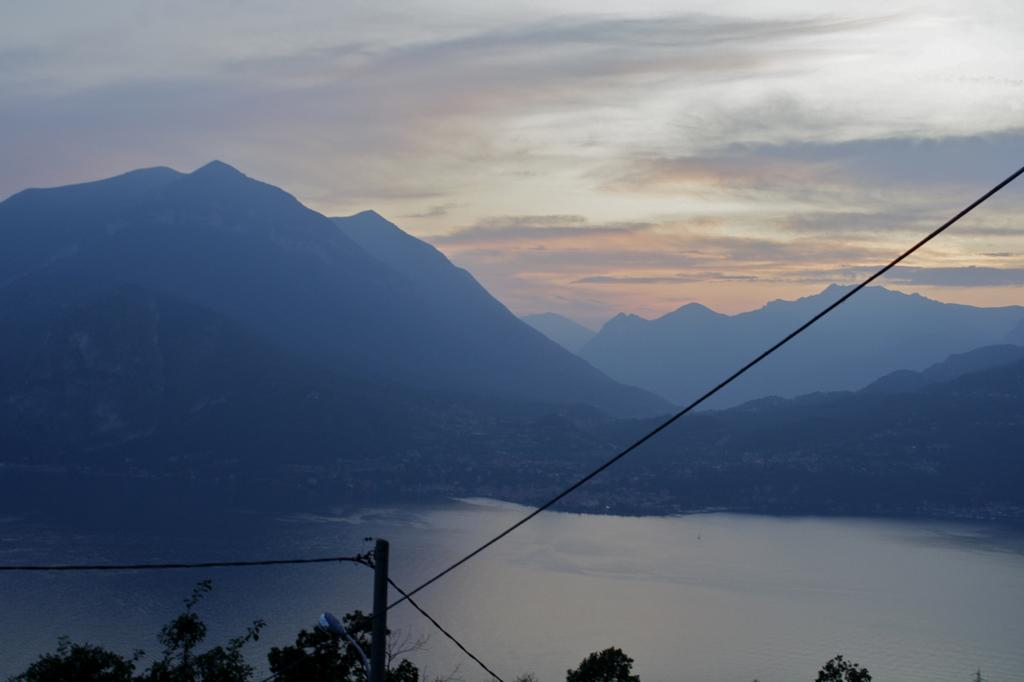What type of vegetation can be seen in the image? There are trees in the image. What natural feature is visible in the image? There is water visible in the image. What geographical feature can be seen in the distance? There are mountains in the image. What is visible at the top of the image? The sky is visible at the top of the image. What type of popcorn can be seen growing on the trees in the image? There is no popcorn present in the image; it is a natural landscape featuring trees, water, mountains, and sky. Can you locate the pin that is holding the mountains together in the image? There is no pin present in the image; the mountains are a natural geological formation. 